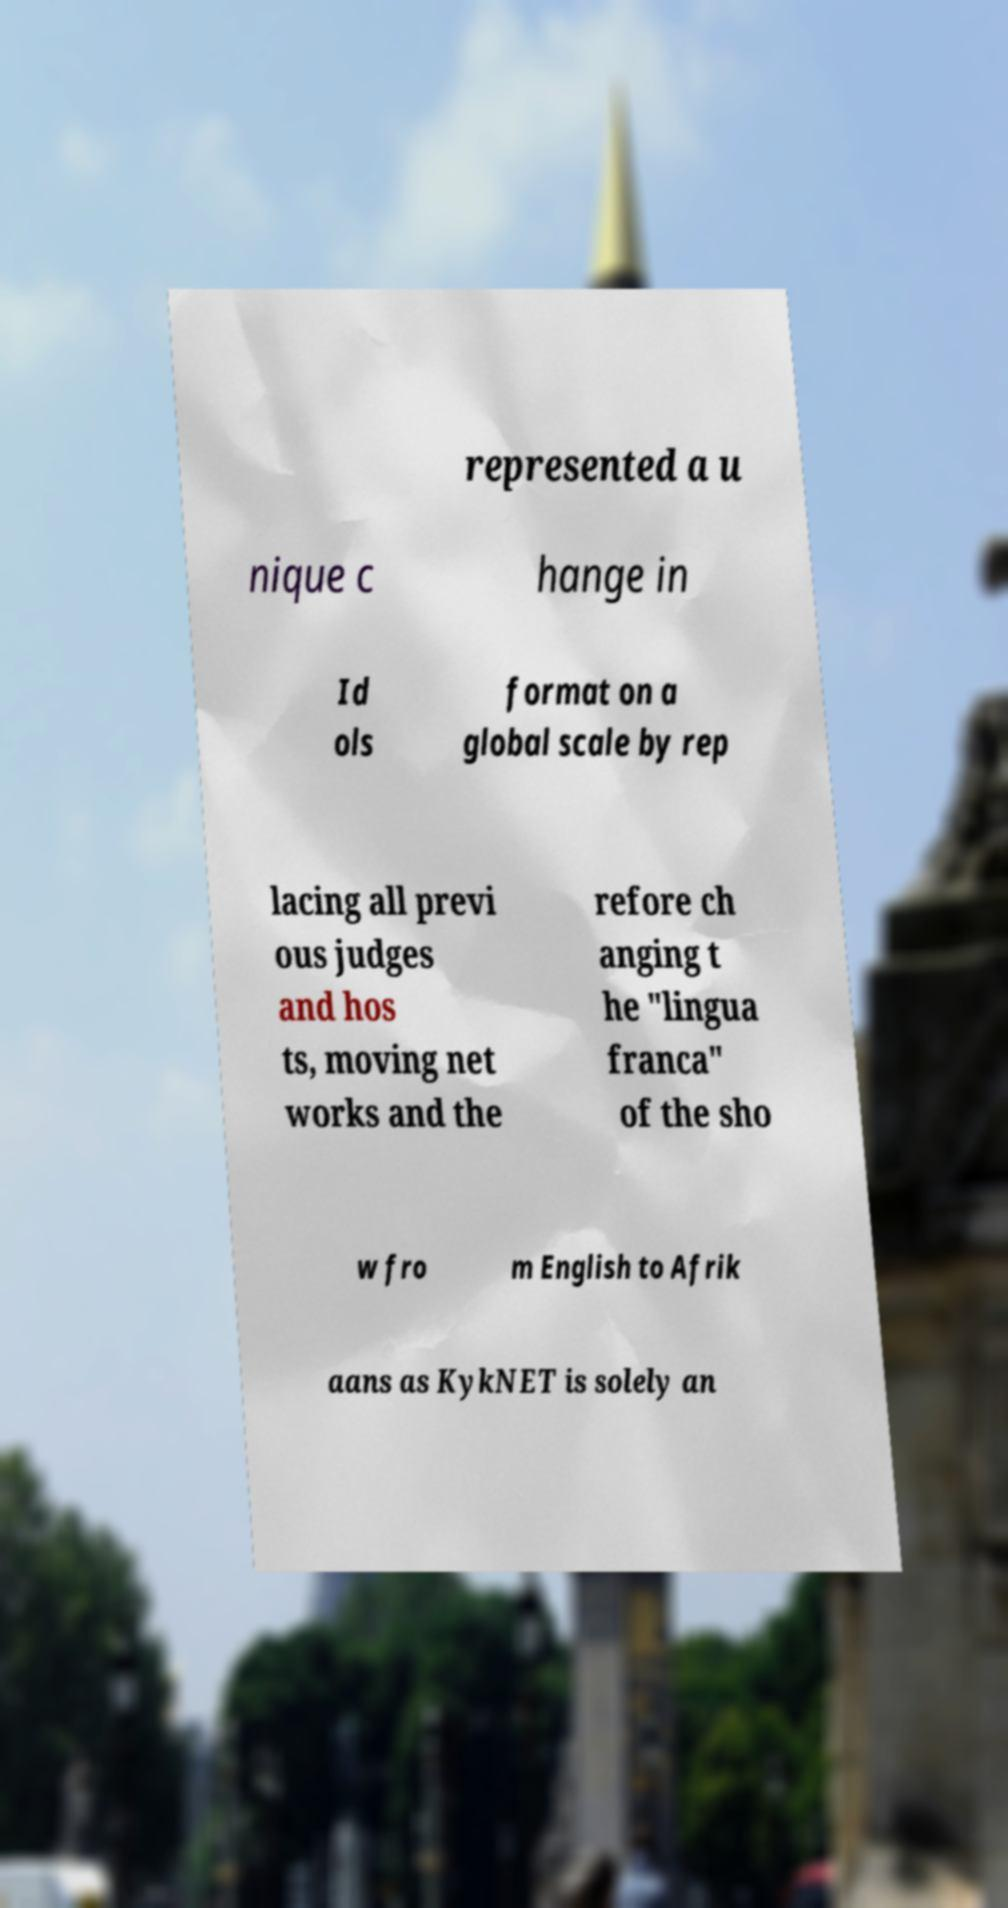Could you extract and type out the text from this image? represented a u nique c hange in Id ols format on a global scale by rep lacing all previ ous judges and hos ts, moving net works and the refore ch anging t he "lingua franca" of the sho w fro m English to Afrik aans as KykNET is solely an 